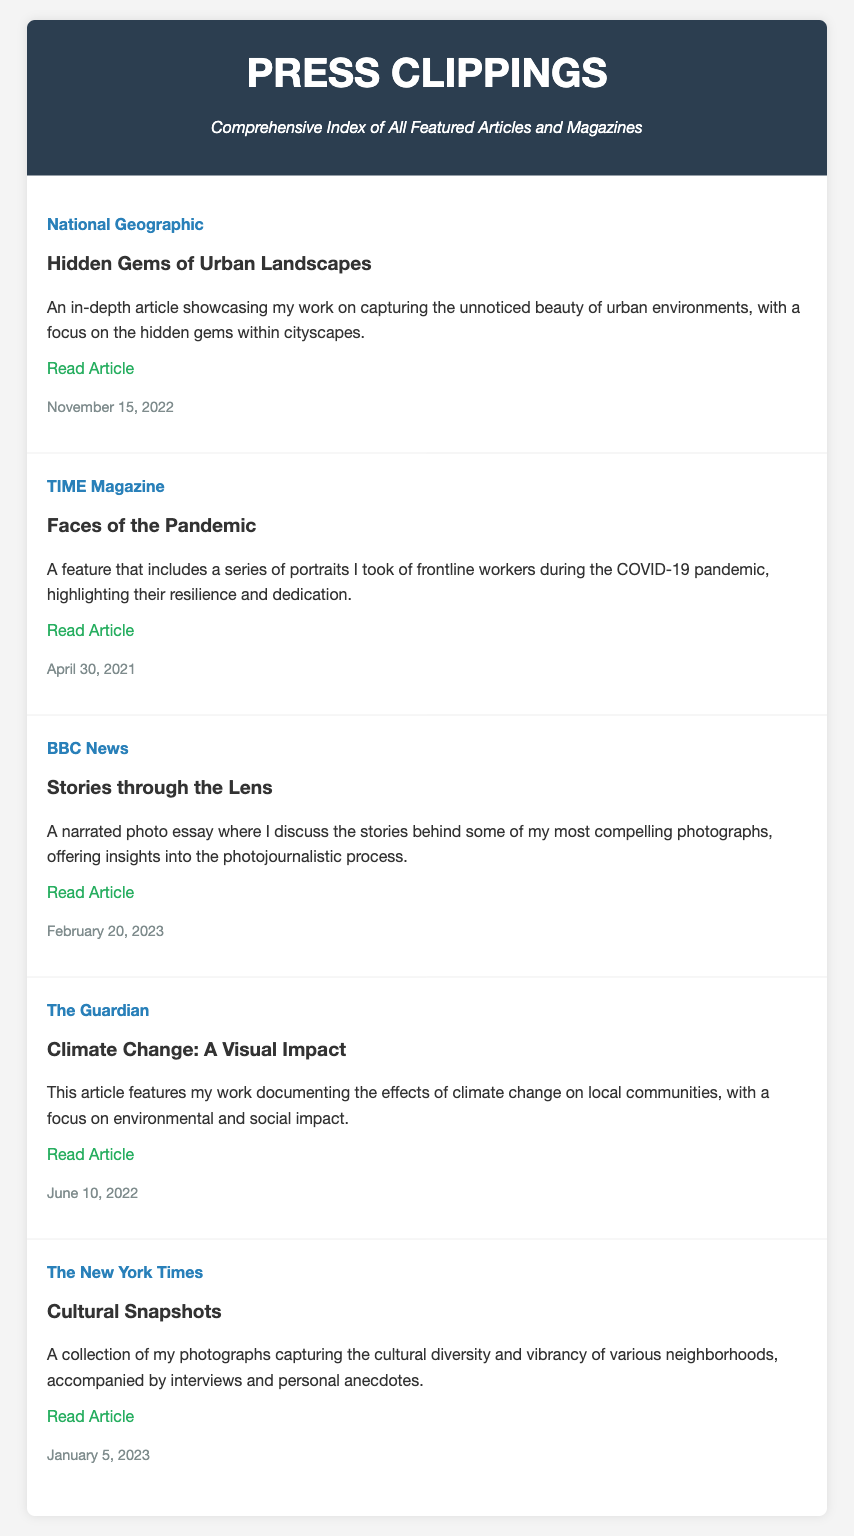What is the title of the article featured in National Geographic? The title is specified in the feature item under National Geographic.
Answer: Hidden Gems of Urban Landscapes When was the article in TIME Magazine published? The date of publication is mentioned in the feature item.
Answer: April 30, 2021 What is the summary of the feature in BBC News? The summary is provided in the corresponding feature item for BBC News.
Answer: A narrated photo essay where I discuss the stories behind some of my most compelling photographs, offering insights into the photojournalistic process Which magazine featured the article about climate change? The source is listed in the feature item detailing the climate change article.
Answer: The Guardian How many articles are listed in the index? The total number of feature items in the document can be counted.
Answer: 5 What is the main focus of the article titled "Faces of the Pandemic"? The main focus is derived from the summary provided in the feature item.
Answer: Portraits of frontline workers during the COVID-19 pandemic Which article discusses the effects of climate change on local communities? The title is given in the feature item that mentions the climate change topic.
Answer: Climate Change: A Visual Impact Who wrote the article featured in The New York Times? The information about the authorship is not directly mentioned in the document, but the works featured are attributed to the photojournalist.
Answer: [Photojournalist's name, assumed to be you] What is the link to the article "Cultural Snapshots"? The link is provided in the feature item under The New York Times.
Answer: https://www.nytimes.com/cultural-snapshots 